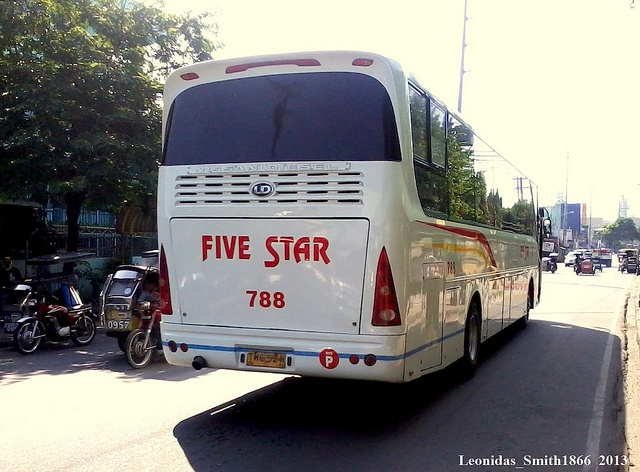Describe the objects in this image and their specific colors. I can see bus in black, darkgray, gray, and navy tones, motorcycle in black, gray, and maroon tones, motorcycle in black, gray, and darkgray tones, car in black, purple, and darkgray tones, and car in black, ivory, darkgray, and gray tones in this image. 